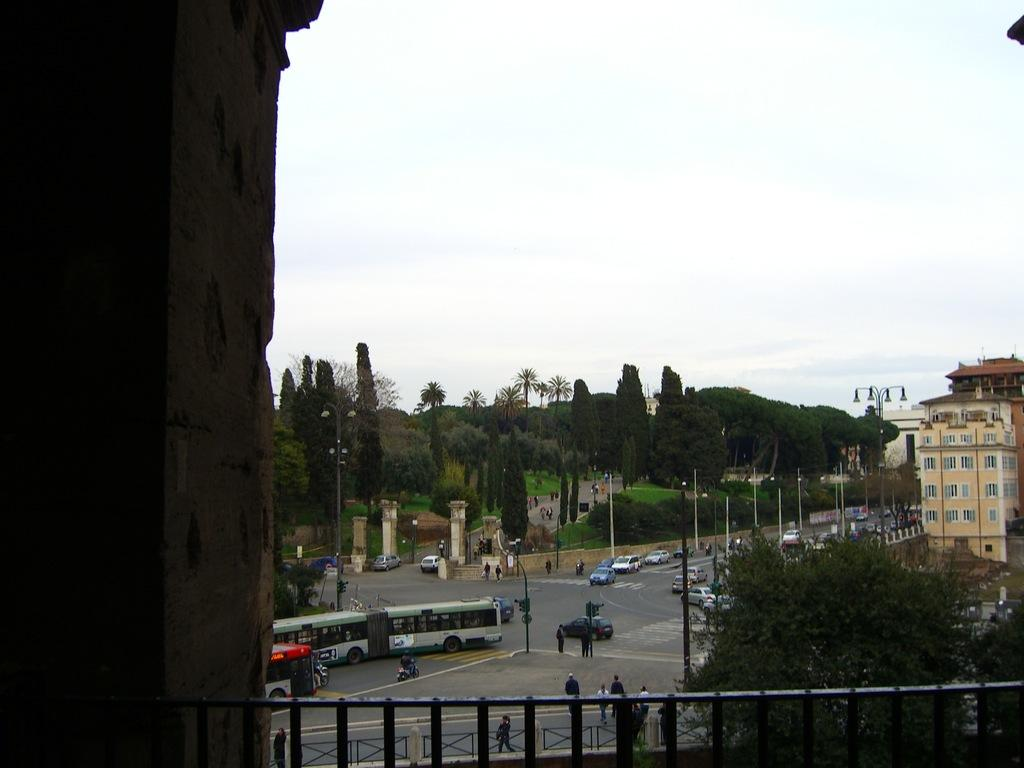What type of structures can be seen in the image? There are railings, trees, poles, pillars, buildings, and grass visible in the image. What else can be seen in the image besides structures? There are people and vehicles on the road in the image. What is visible in the background of the image? The sky is visible in the background of the image. Can you see any spark coming from the railings in the image? There is no spark visible on the railings in the image. How many birds are sitting on the grass in the image? There are no birds present in the image; it features railings, trees, poles, pillars, buildings, people, vehicles, and grass. 